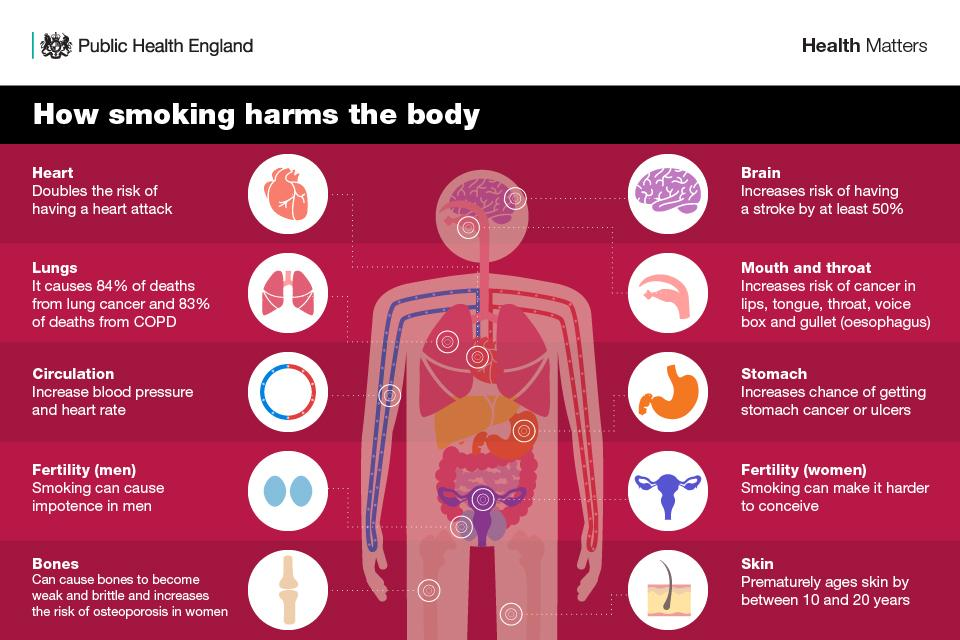Highlight a few significant elements in this photo. In the United States, lung cancer is responsible for approximately 84% of all deaths caused by cancer. Smoking is a significant hindrance to conception in females. Osteoporosis is a disease that affects the bones and is caused by smoking. The color of the stomach depicted in the image is orange. There are 10 circles on either side of the body. 